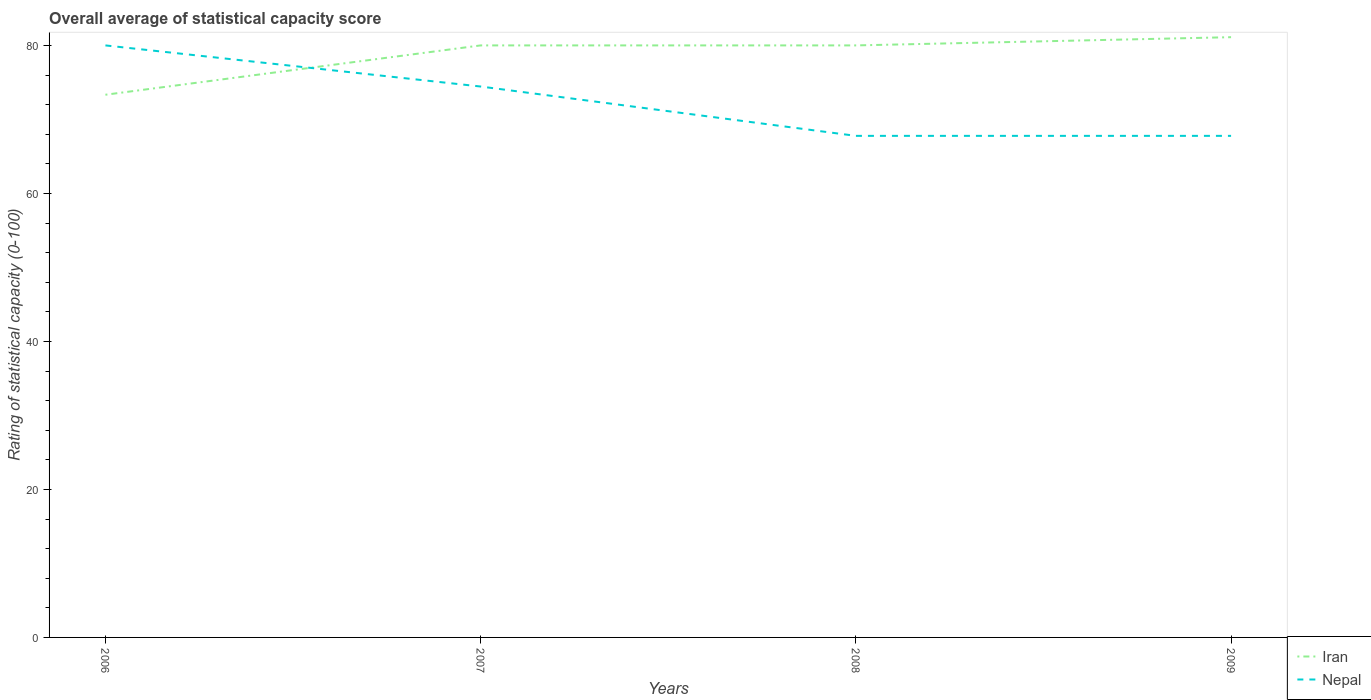How many different coloured lines are there?
Offer a terse response. 2. Is the number of lines equal to the number of legend labels?
Give a very brief answer. Yes. Across all years, what is the maximum rating of statistical capacity in Nepal?
Provide a succinct answer. 67.78. In which year was the rating of statistical capacity in Iran maximum?
Give a very brief answer. 2006. What is the total rating of statistical capacity in Nepal in the graph?
Offer a terse response. 6.67. What is the difference between the highest and the second highest rating of statistical capacity in Iran?
Make the answer very short. 7.78. What is the difference between the highest and the lowest rating of statistical capacity in Iran?
Offer a terse response. 3. Is the rating of statistical capacity in Iran strictly greater than the rating of statistical capacity in Nepal over the years?
Make the answer very short. No. What is the difference between two consecutive major ticks on the Y-axis?
Your response must be concise. 20. Does the graph contain any zero values?
Make the answer very short. No. Does the graph contain grids?
Ensure brevity in your answer.  No. What is the title of the graph?
Your answer should be very brief. Overall average of statistical capacity score. Does "Isle of Man" appear as one of the legend labels in the graph?
Your answer should be very brief. No. What is the label or title of the X-axis?
Keep it short and to the point. Years. What is the label or title of the Y-axis?
Your answer should be very brief. Rating of statistical capacity (0-100). What is the Rating of statistical capacity (0-100) in Iran in 2006?
Your answer should be compact. 73.33. What is the Rating of statistical capacity (0-100) in Nepal in 2006?
Your response must be concise. 80. What is the Rating of statistical capacity (0-100) in Iran in 2007?
Give a very brief answer. 80. What is the Rating of statistical capacity (0-100) of Nepal in 2007?
Your answer should be very brief. 74.44. What is the Rating of statistical capacity (0-100) of Iran in 2008?
Offer a very short reply. 80. What is the Rating of statistical capacity (0-100) in Nepal in 2008?
Your answer should be compact. 67.78. What is the Rating of statistical capacity (0-100) in Iran in 2009?
Offer a very short reply. 81.11. What is the Rating of statistical capacity (0-100) in Nepal in 2009?
Your response must be concise. 67.78. Across all years, what is the maximum Rating of statistical capacity (0-100) in Iran?
Provide a short and direct response. 81.11. Across all years, what is the maximum Rating of statistical capacity (0-100) of Nepal?
Provide a succinct answer. 80. Across all years, what is the minimum Rating of statistical capacity (0-100) in Iran?
Make the answer very short. 73.33. Across all years, what is the minimum Rating of statistical capacity (0-100) in Nepal?
Give a very brief answer. 67.78. What is the total Rating of statistical capacity (0-100) in Iran in the graph?
Make the answer very short. 314.44. What is the total Rating of statistical capacity (0-100) of Nepal in the graph?
Give a very brief answer. 290. What is the difference between the Rating of statistical capacity (0-100) in Iran in 2006 and that in 2007?
Provide a succinct answer. -6.67. What is the difference between the Rating of statistical capacity (0-100) of Nepal in 2006 and that in 2007?
Offer a terse response. 5.56. What is the difference between the Rating of statistical capacity (0-100) of Iran in 2006 and that in 2008?
Provide a succinct answer. -6.67. What is the difference between the Rating of statistical capacity (0-100) of Nepal in 2006 and that in 2008?
Offer a terse response. 12.22. What is the difference between the Rating of statistical capacity (0-100) in Iran in 2006 and that in 2009?
Your response must be concise. -7.78. What is the difference between the Rating of statistical capacity (0-100) of Nepal in 2006 and that in 2009?
Provide a short and direct response. 12.22. What is the difference between the Rating of statistical capacity (0-100) of Iran in 2007 and that in 2008?
Your answer should be compact. 0. What is the difference between the Rating of statistical capacity (0-100) in Iran in 2007 and that in 2009?
Your response must be concise. -1.11. What is the difference between the Rating of statistical capacity (0-100) of Nepal in 2007 and that in 2009?
Give a very brief answer. 6.67. What is the difference between the Rating of statistical capacity (0-100) of Iran in 2008 and that in 2009?
Ensure brevity in your answer.  -1.11. What is the difference between the Rating of statistical capacity (0-100) of Iran in 2006 and the Rating of statistical capacity (0-100) of Nepal in 2007?
Provide a short and direct response. -1.11. What is the difference between the Rating of statistical capacity (0-100) in Iran in 2006 and the Rating of statistical capacity (0-100) in Nepal in 2008?
Provide a short and direct response. 5.56. What is the difference between the Rating of statistical capacity (0-100) of Iran in 2006 and the Rating of statistical capacity (0-100) of Nepal in 2009?
Ensure brevity in your answer.  5.56. What is the difference between the Rating of statistical capacity (0-100) in Iran in 2007 and the Rating of statistical capacity (0-100) in Nepal in 2008?
Your answer should be very brief. 12.22. What is the difference between the Rating of statistical capacity (0-100) of Iran in 2007 and the Rating of statistical capacity (0-100) of Nepal in 2009?
Offer a very short reply. 12.22. What is the difference between the Rating of statistical capacity (0-100) of Iran in 2008 and the Rating of statistical capacity (0-100) of Nepal in 2009?
Ensure brevity in your answer.  12.22. What is the average Rating of statistical capacity (0-100) of Iran per year?
Provide a short and direct response. 78.61. What is the average Rating of statistical capacity (0-100) of Nepal per year?
Offer a very short reply. 72.5. In the year 2006, what is the difference between the Rating of statistical capacity (0-100) in Iran and Rating of statistical capacity (0-100) in Nepal?
Make the answer very short. -6.67. In the year 2007, what is the difference between the Rating of statistical capacity (0-100) in Iran and Rating of statistical capacity (0-100) in Nepal?
Keep it short and to the point. 5.56. In the year 2008, what is the difference between the Rating of statistical capacity (0-100) of Iran and Rating of statistical capacity (0-100) of Nepal?
Keep it short and to the point. 12.22. In the year 2009, what is the difference between the Rating of statistical capacity (0-100) in Iran and Rating of statistical capacity (0-100) in Nepal?
Provide a succinct answer. 13.33. What is the ratio of the Rating of statistical capacity (0-100) of Iran in 2006 to that in 2007?
Provide a succinct answer. 0.92. What is the ratio of the Rating of statistical capacity (0-100) of Nepal in 2006 to that in 2007?
Ensure brevity in your answer.  1.07. What is the ratio of the Rating of statistical capacity (0-100) of Iran in 2006 to that in 2008?
Keep it short and to the point. 0.92. What is the ratio of the Rating of statistical capacity (0-100) of Nepal in 2006 to that in 2008?
Your response must be concise. 1.18. What is the ratio of the Rating of statistical capacity (0-100) in Iran in 2006 to that in 2009?
Ensure brevity in your answer.  0.9. What is the ratio of the Rating of statistical capacity (0-100) of Nepal in 2006 to that in 2009?
Give a very brief answer. 1.18. What is the ratio of the Rating of statistical capacity (0-100) of Nepal in 2007 to that in 2008?
Provide a succinct answer. 1.1. What is the ratio of the Rating of statistical capacity (0-100) of Iran in 2007 to that in 2009?
Offer a very short reply. 0.99. What is the ratio of the Rating of statistical capacity (0-100) of Nepal in 2007 to that in 2009?
Ensure brevity in your answer.  1.1. What is the ratio of the Rating of statistical capacity (0-100) in Iran in 2008 to that in 2009?
Provide a short and direct response. 0.99. What is the difference between the highest and the second highest Rating of statistical capacity (0-100) in Iran?
Give a very brief answer. 1.11. What is the difference between the highest and the second highest Rating of statistical capacity (0-100) in Nepal?
Keep it short and to the point. 5.56. What is the difference between the highest and the lowest Rating of statistical capacity (0-100) of Iran?
Provide a short and direct response. 7.78. What is the difference between the highest and the lowest Rating of statistical capacity (0-100) in Nepal?
Ensure brevity in your answer.  12.22. 